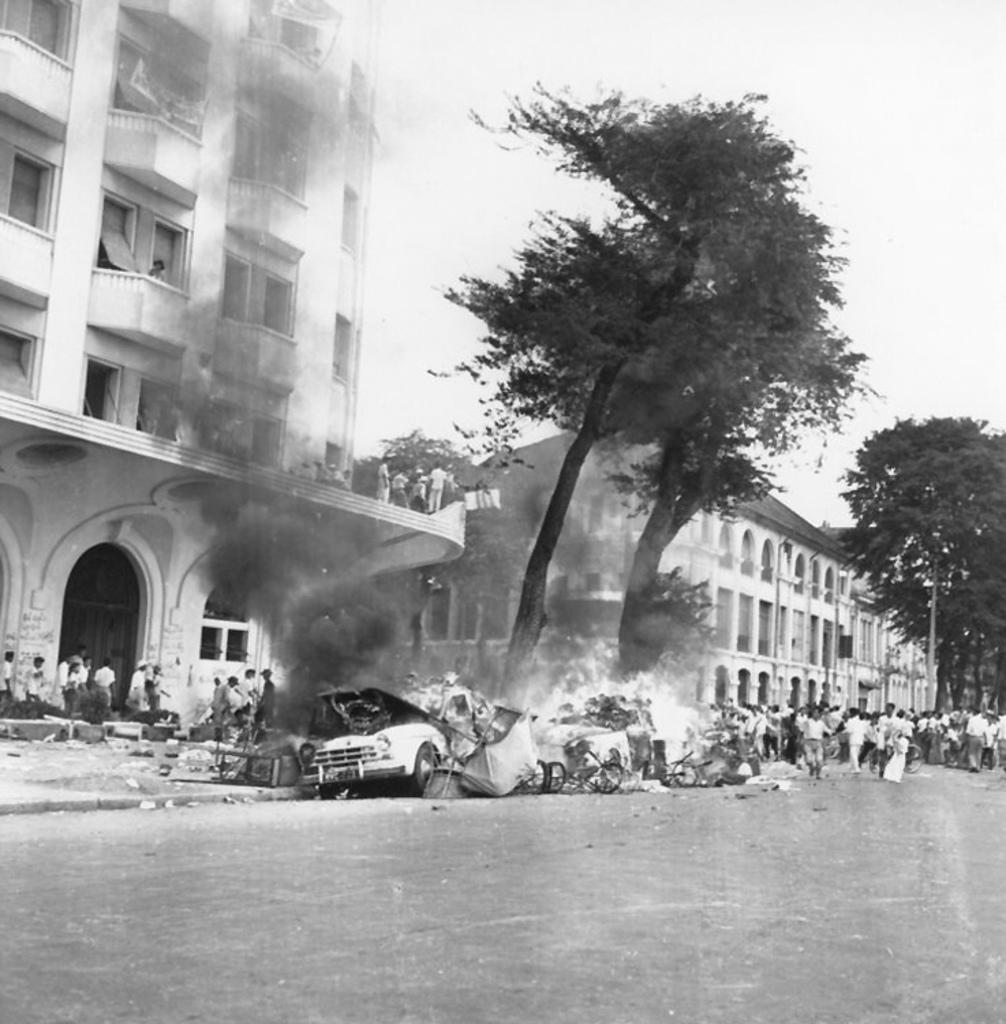Describe this image in one or two sentences. This is a black and white image. In the middle of the image I can see few vehicles are burning in the fire. There are some trees. On the right side, I can see a crowd of people on the road. In the background there are few buildings. At the top, I can see the sky. 